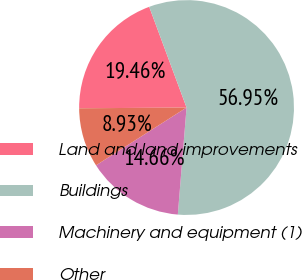Convert chart to OTSL. <chart><loc_0><loc_0><loc_500><loc_500><pie_chart><fcel>Land and land improvements<fcel>Buildings<fcel>Machinery and equipment (1)<fcel>Other<nl><fcel>19.46%<fcel>56.95%<fcel>14.66%<fcel>8.93%<nl></chart> 